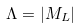Convert formula to latex. <formula><loc_0><loc_0><loc_500><loc_500>\Lambda = | M _ { L } |</formula> 